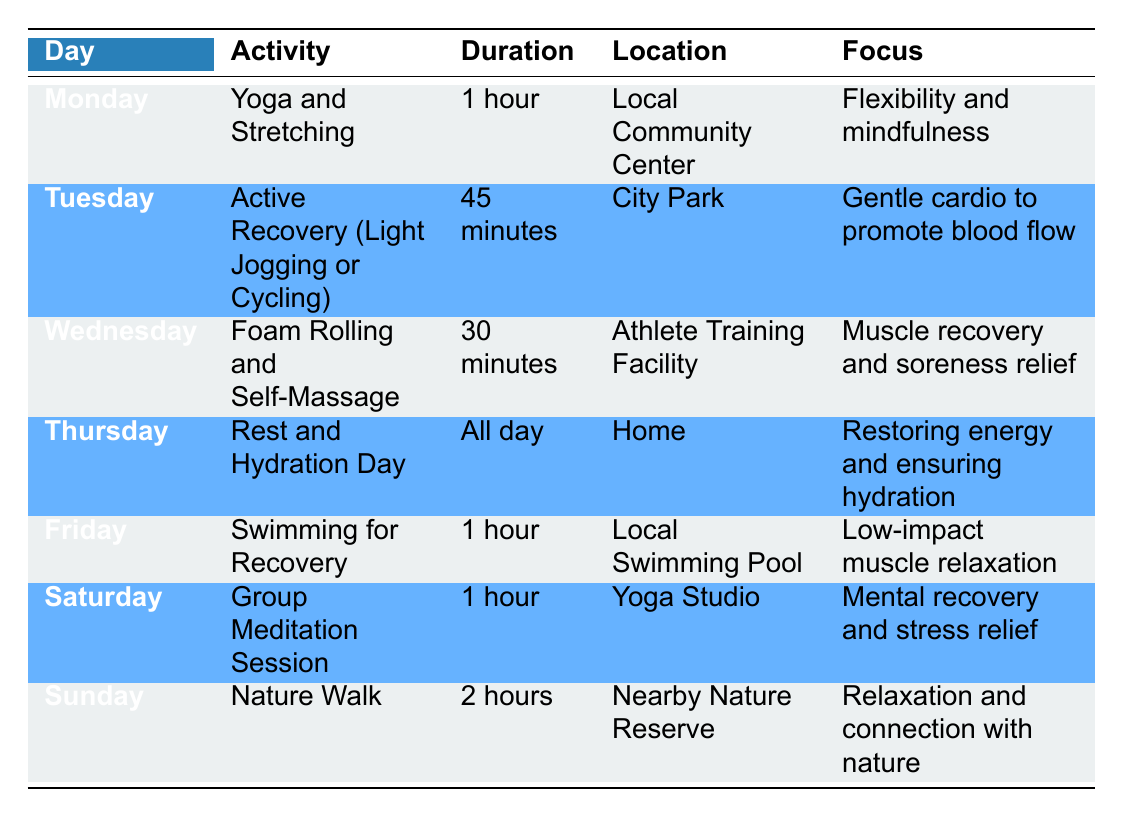What activity is scheduled for Wednesday? The table lists the activities for each day of the week. By looking at the row for Wednesday, we can see that the scheduled activity is "Foam Rolling and Self-Massage."
Answer: Foam Rolling and Self-Massage How long is the Yoga and Stretching session on Monday? The duration of the Yoga and Stretching session is listed directly in the row for Monday. It is explicitly stated that the duration is "1 hour."
Answer: 1 hour On which day is there a focus on "Restoring energy and ensuring hydration"? The specified focus can be found in the row corresponding to Thursday. This row explicitly says the focus is on "Restoring energy and ensuring hydration."
Answer: Thursday What is the total duration of recovery activities planned on Saturday and Sunday combined? Saturday has a recovery activity duration of "1 hour" (Group Meditation Session) and Sunday has "2 hours" (Nature Walk). To find the total, we sum these durations: 1 hour + 2 hours = 3 hours.
Answer: 3 hours Is there a recovery activity involving water-based exercise? By examining the table, we can see that there is a swimming activity listed on Friday, which is specifically for recovery. Therefore, the answer is yes.
Answer: Yes Which activity provides the most focus on mental recovery? The activity focused on mental recovery is "Group Meditation Session," which is scheduled for Saturday. This can be found by reading the focus description in the corresponding row.
Answer: Group Meditation Session On what day do athletes engage in active recovery, and how long does it last? The Active Recovery session occurs on Tuesday, with a duration of "45 minutes." This information is referenced directly from the Tuesday row.
Answer: Tuesday, 45 minutes What is the primary focus of Friday's activity? The focus of Friday's activity is labeled as "Low-impact muscle relaxation," which can be found under the activity "Swimming for Recovery."
Answer: Low-impact muscle relaxation 